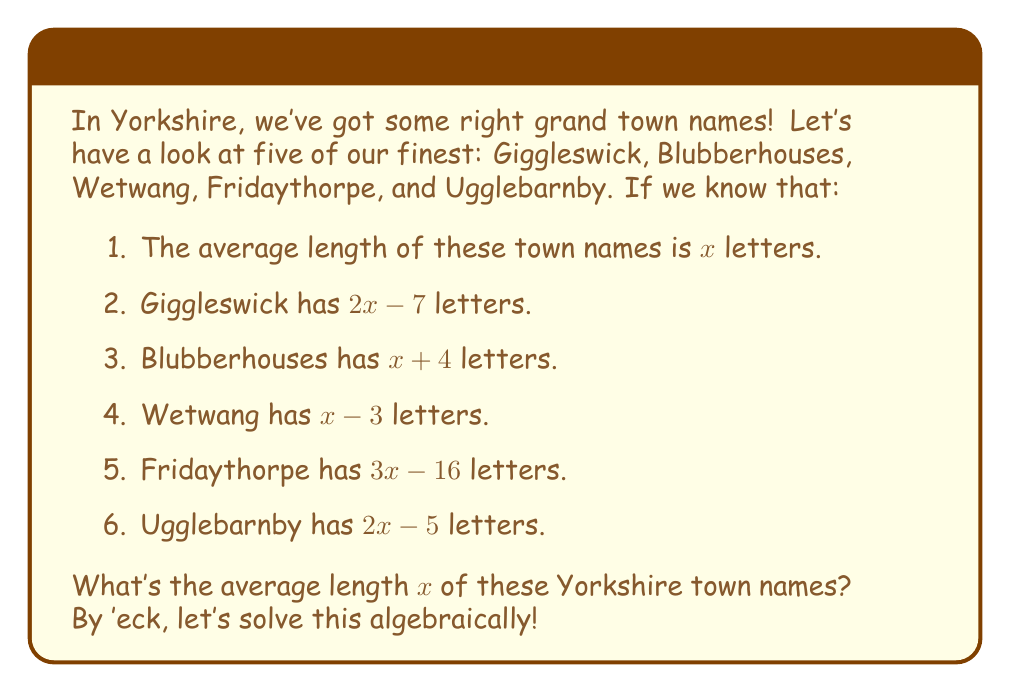Solve this math problem. Right, let's tackle this step by step:

1) First, we know that the sum of all the letters divided by 5 (as there are 5 towns) should equal $x$:

   $$ \frac{(2x-7) + (x+4) + (x-3) + (3x-16) + (2x-5)}{5} = x $$

2) Let's simplify the numerator:

   $$ \frac{9x - 27}{5} = x $$

3) Now, let's multiply both sides by 5:

   $$ 9x - 27 = 5x $$

4) Subtract 5x from both sides:

   $$ 4x - 27 = 0 $$

5) Add 27 to both sides:

   $$ 4x = 27 $$

6) Finally, divide both sides by 4:

   $$ x = \frac{27}{4} = 6.75 $$

Therefore, the average length of these Yorkshire town names is 6.75 letters.
Answer: $x = 6.75$ letters 